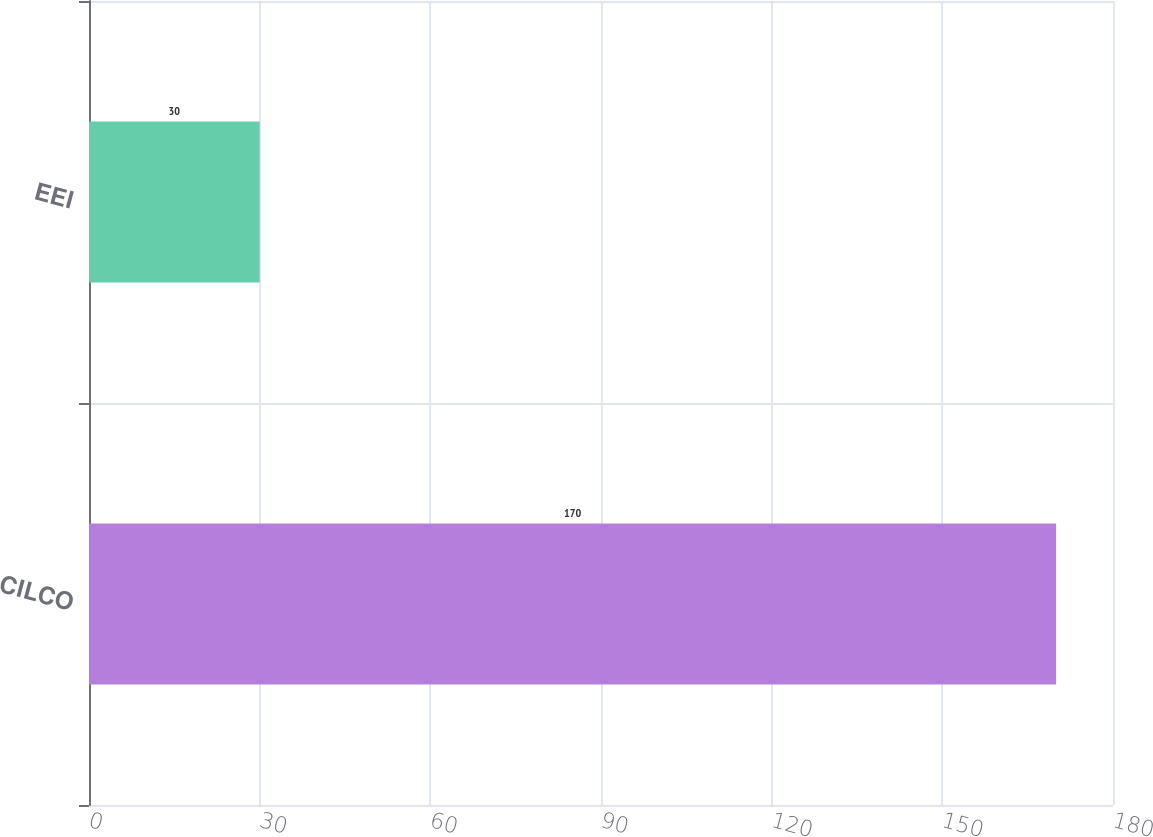Convert chart to OTSL. <chart><loc_0><loc_0><loc_500><loc_500><bar_chart><fcel>CILCO<fcel>EEI<nl><fcel>170<fcel>30<nl></chart> 